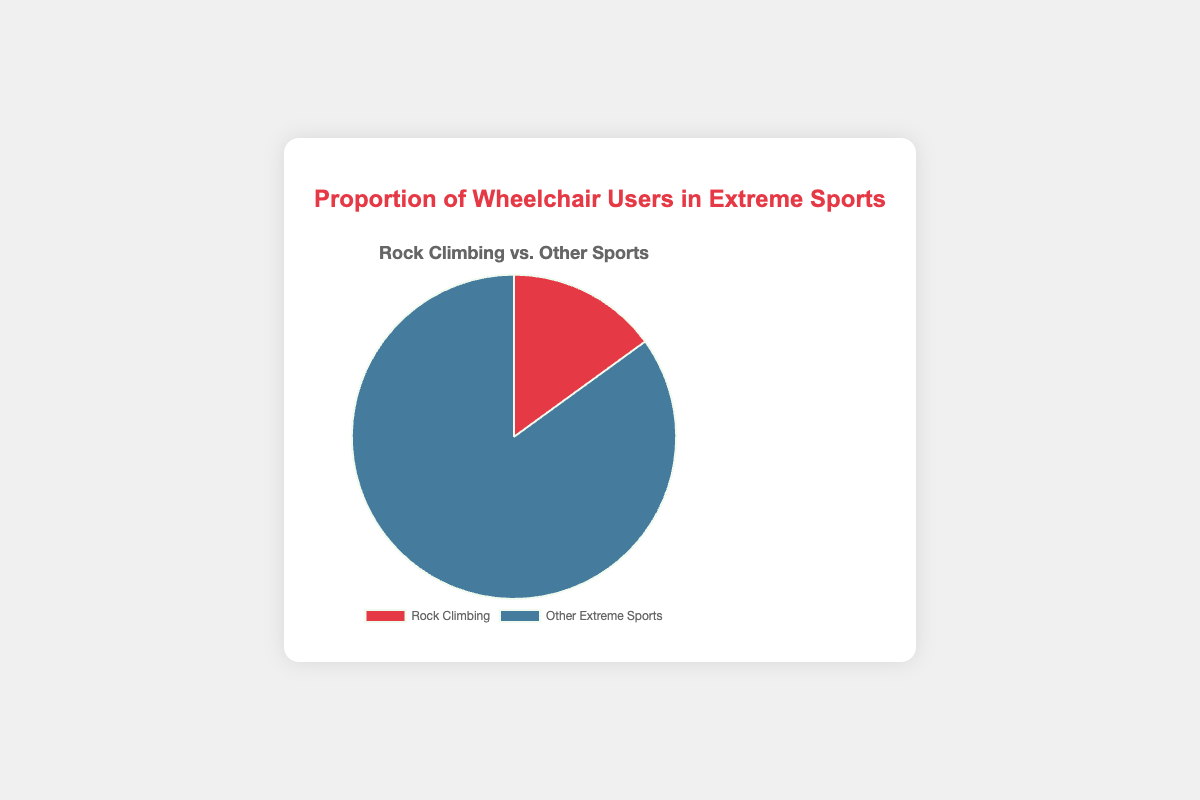What proportion of wheelchair users in extreme sports participate in rock climbing? The chart shows two segments, one for rock climbing and one for other extreme sports. The proportion for rock climbing is explicitly given as a percentage.
Answer: 15% How much higher is the proportion of wheelchair users in other extreme sports compared to rock climbing? The chart gives the proportion for rock climbing as 15% and for other extreme sports as 85%. The difference is calculated by subtracting 15 from 85.
Answer: 70% Which segment represents the larger proportion of wheelchair users, rock climbing or other extreme sports? By comparing the two segments, the segment representing other extreme sports is larger at 85%, while rock climbing is 15%.
Answer: Other extreme sports What percentage of wheelchair users in extreme sports do not participate in rock climbing? The chart indicates that 15% of wheelchair users participate in rock climbing. Therefore, the remaining percentage is 100% - 15%.
Answer: 85% If you combine the proportions, what is the total? Adding the given proportions for rock climbing (15%) and other extreme sports (85%) results in the total proportion.
Answer: 100% Is the pie chart evenly divided between rock climbing and other extreme sports? Visually examining the chart, one segment (other extreme sports) is significantly larger than the other (rock climbing), indicating an uneven division.
Answer: No If you were to create another segment in the pie for a new extreme sport, how would the current proportions change assuming equal participants in the new sport? With three equal segments, each would be 100% / 3, which is approximately 33.3%. This is a significant shift since the current proportions are 15% and 85%. A recalculation would be needed for precise answers.
Answer: They would decrease significantly What color represents rock climbing in the pie chart? The chart uses two colors. The segment corresponding to rock climbing is clearly colored differently from the segment for other extreme sports.
Answer: Red If the proportions represented the number of wheelchair users per 100 participants in extreme sports, how many users would that be for rock climbing and other extreme sports? For rock climbing, 15 out of 100 participants are users. For other extreme sports, it's 85 out of 100. Multiply these proportions by 100 to get the actual numbers.
Answer: 15 for rock climbing, 85 for other extreme sports How many times greater is the proportion of wheelchair users in other extreme sports compared to rock climbing? Calculate the ratio of the two proportions: 85% / 15%. This equals 5.67, meaning other extreme sports have a proportion that is 5.67 times greater.
Answer: 5.67 times 